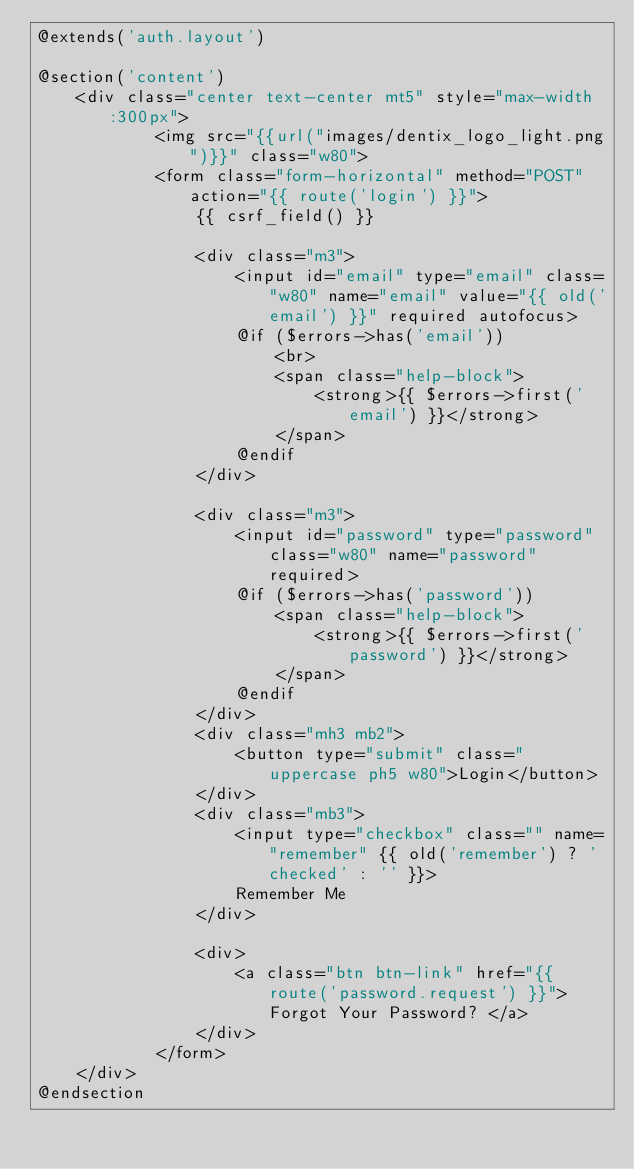Convert code to text. <code><loc_0><loc_0><loc_500><loc_500><_PHP_>@extends('auth.layout')

@section('content')
    <div class="center text-center mt5" style="max-width:300px">
            <img src="{{url("images/dentix_logo_light.png")}}" class="w80">
            <form class="form-horizontal" method="POST" action="{{ route('login') }}">
                {{ csrf_field() }}

                <div class="m3">
                    <input id="email" type="email" class="w80" name="email" value="{{ old('email') }}" required autofocus>
                    @if ($errors->has('email'))
                        <br>
                        <span class="help-block">
                            <strong>{{ $errors->first('email') }}</strong>
                        </span>
                    @endif
                </div>

                <div class="m3">
                    <input id="password" type="password" class="w80" name="password" required>
                    @if ($errors->has('password'))
                        <span class="help-block">
                            <strong>{{ $errors->first('password') }}</strong>
                        </span>
                    @endif
                </div>
                <div class="mh3 mb2">
                    <button type="submit" class="uppercase ph5 w80">Login</button>
                </div>
                <div class="mb3">
                    <input type="checkbox" class="" name="remember" {{ old('remember') ? 'checked' : '' }}>
                    Remember Me
                </div>

                <div>
                    <a class="btn btn-link" href="{{ route('password.request') }}"> Forgot Your Password? </a>
                </div>
            </form>
    </div>
@endsection
</code> 